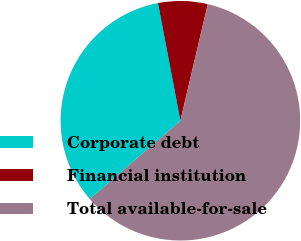Convert chart. <chart><loc_0><loc_0><loc_500><loc_500><pie_chart><fcel>Corporate debt<fcel>Financial institution<fcel>Total available-for-sale<nl><fcel>33.33%<fcel>6.67%<fcel>60.0%<nl></chart> 